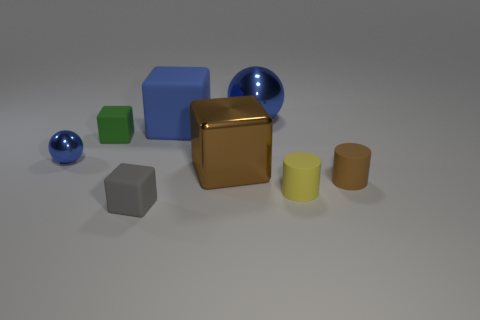Subtract 1 cubes. How many cubes are left? 3 Add 1 tiny blue objects. How many objects exist? 9 Subtract all balls. How many objects are left? 6 Add 2 yellow metal things. How many yellow metal things exist? 2 Subtract 1 blue cubes. How many objects are left? 7 Subtract all gray matte blocks. Subtract all tiny yellow cylinders. How many objects are left? 6 Add 1 large brown metal blocks. How many large brown metal blocks are left? 2 